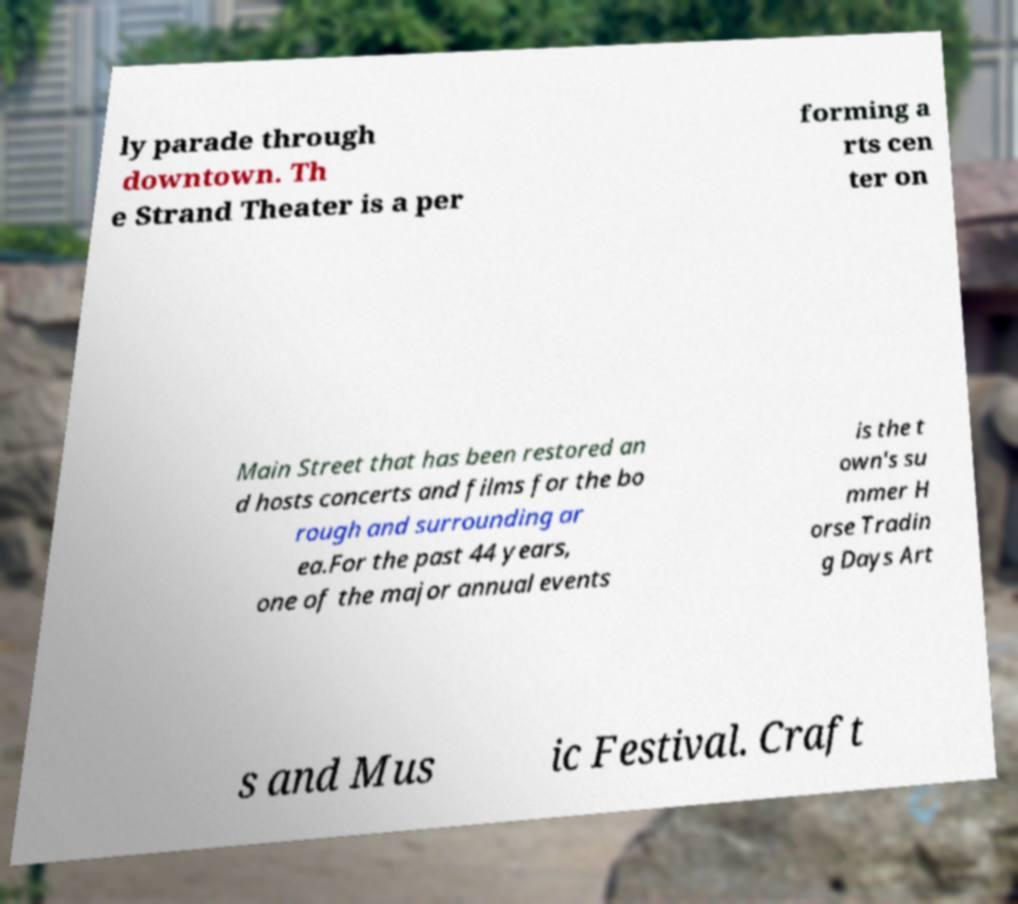What messages or text are displayed in this image? I need them in a readable, typed format. ly parade through downtown. Th e Strand Theater is a per forming a rts cen ter on Main Street that has been restored an d hosts concerts and films for the bo rough and surrounding ar ea.For the past 44 years, one of the major annual events is the t own's su mmer H orse Tradin g Days Art s and Mus ic Festival. Craft 